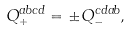<formula> <loc_0><loc_0><loc_500><loc_500>Q _ { + } ^ { a b c d } = \pm Q _ { - } ^ { c d a b } ,</formula> 